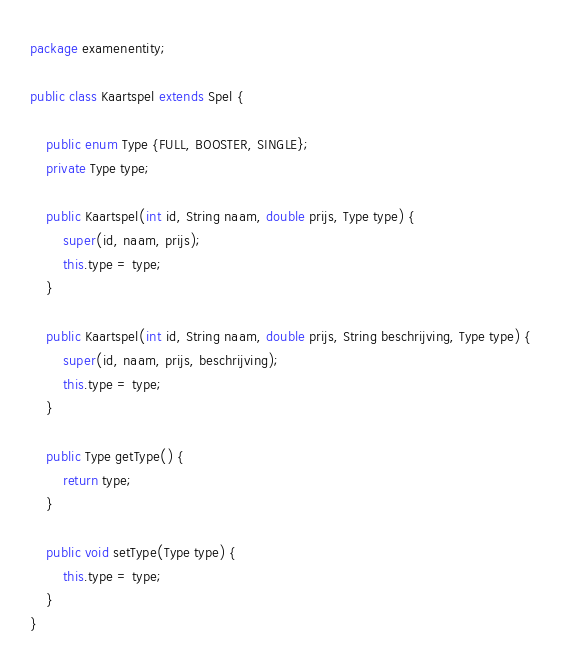Convert code to text. <code><loc_0><loc_0><loc_500><loc_500><_Java_>package examenentity;

public class Kaartspel extends Spel {

    public enum Type {FULL, BOOSTER, SINGLE};
    private Type type;

    public Kaartspel(int id, String naam, double prijs, Type type) {
        super(id, naam, prijs);
        this.type = type;
    }

    public Kaartspel(int id, String naam, double prijs, String beschrijving, Type type) {
        super(id, naam, prijs, beschrijving);
        this.type = type;
    }

    public Type getType() {
        return type;
    }

    public void setType(Type type) {
        this.type = type;
    }
}
</code> 